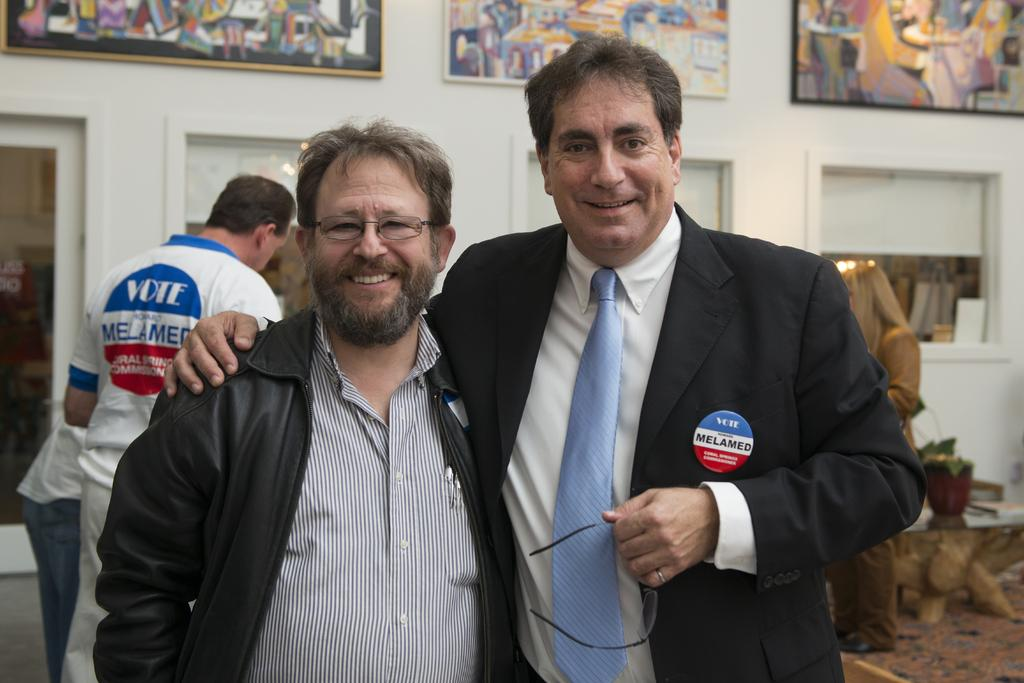How many people are in the image? There are two men standing in the middle of the image. What are the men doing in the image? The men are smiling in the image. What are the men wearing in the image? The men are wearing coats in the image. What can be seen on the wall in the image? There are painted photo frames on the wall at the top of the image. What type of door is visible in the image? There is no door present in the image. What is the men sitting on in the image? The men are standing in the image, not sitting, and there is no throne or any other seating visible. 